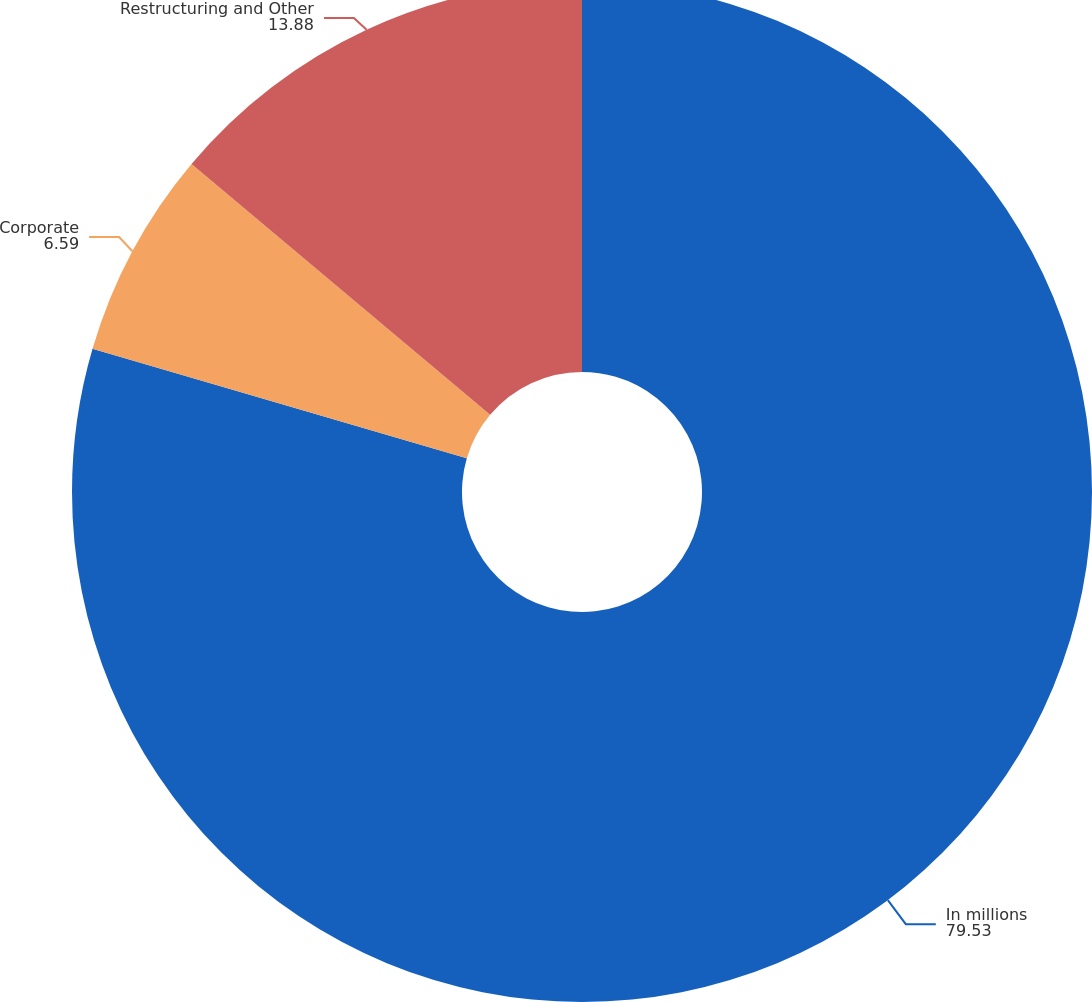<chart> <loc_0><loc_0><loc_500><loc_500><pie_chart><fcel>In millions<fcel>Corporate<fcel>Restructuring and Other<nl><fcel>79.53%<fcel>6.59%<fcel>13.88%<nl></chart> 